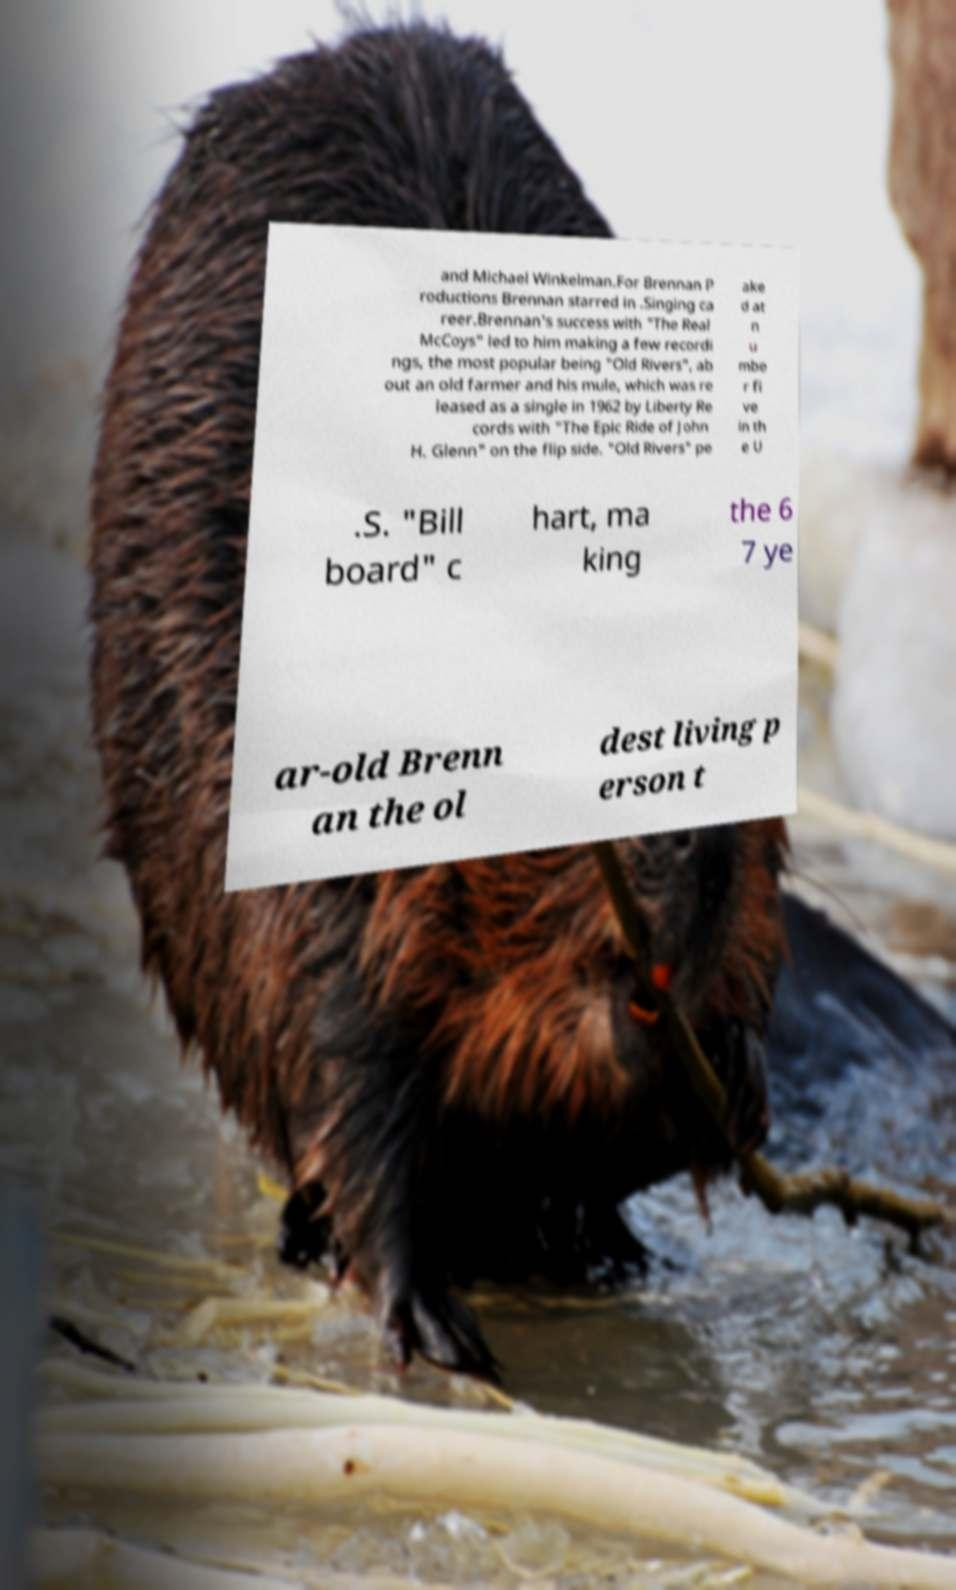Can you read and provide the text displayed in the image?This photo seems to have some interesting text. Can you extract and type it out for me? and Michael Winkelman.For Brennan P roductions Brennan starred in .Singing ca reer.Brennan's success with "The Real McCoys" led to him making a few recordi ngs, the most popular being "Old Rivers", ab out an old farmer and his mule, which was re leased as a single in 1962 by Liberty Re cords with "The Epic Ride of John H. Glenn" on the flip side. "Old Rivers" pe ake d at n u mbe r fi ve in th e U .S. "Bill board" c hart, ma king the 6 7 ye ar-old Brenn an the ol dest living p erson t 